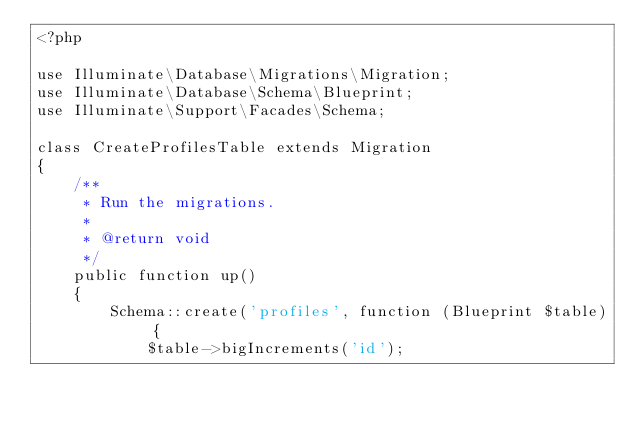Convert code to text. <code><loc_0><loc_0><loc_500><loc_500><_PHP_><?php

use Illuminate\Database\Migrations\Migration;
use Illuminate\Database\Schema\Blueprint;
use Illuminate\Support\Facades\Schema;

class CreateProfilesTable extends Migration
{
    /**
     * Run the migrations.
     *
     * @return void
     */
    public function up()
    {
        Schema::create('profiles', function (Blueprint $table) {
            $table->bigIncrements('id');</code> 